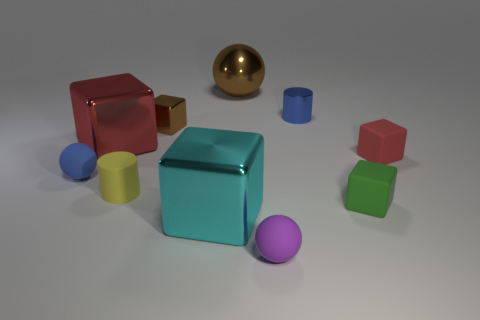Subtract all purple matte balls. How many balls are left? 2 Subtract all purple balls. How many balls are left? 2 Subtract all cylinders. How many objects are left? 8 Subtract 1 spheres. How many spheres are left? 2 Subtract all tiny green cubes. Subtract all big blocks. How many objects are left? 7 Add 6 yellow rubber things. How many yellow rubber things are left? 7 Add 3 big yellow rubber cylinders. How many big yellow rubber cylinders exist? 3 Subtract 0 yellow blocks. How many objects are left? 10 Subtract all gray cubes. Subtract all red cylinders. How many cubes are left? 5 Subtract all blue blocks. How many purple cylinders are left? 0 